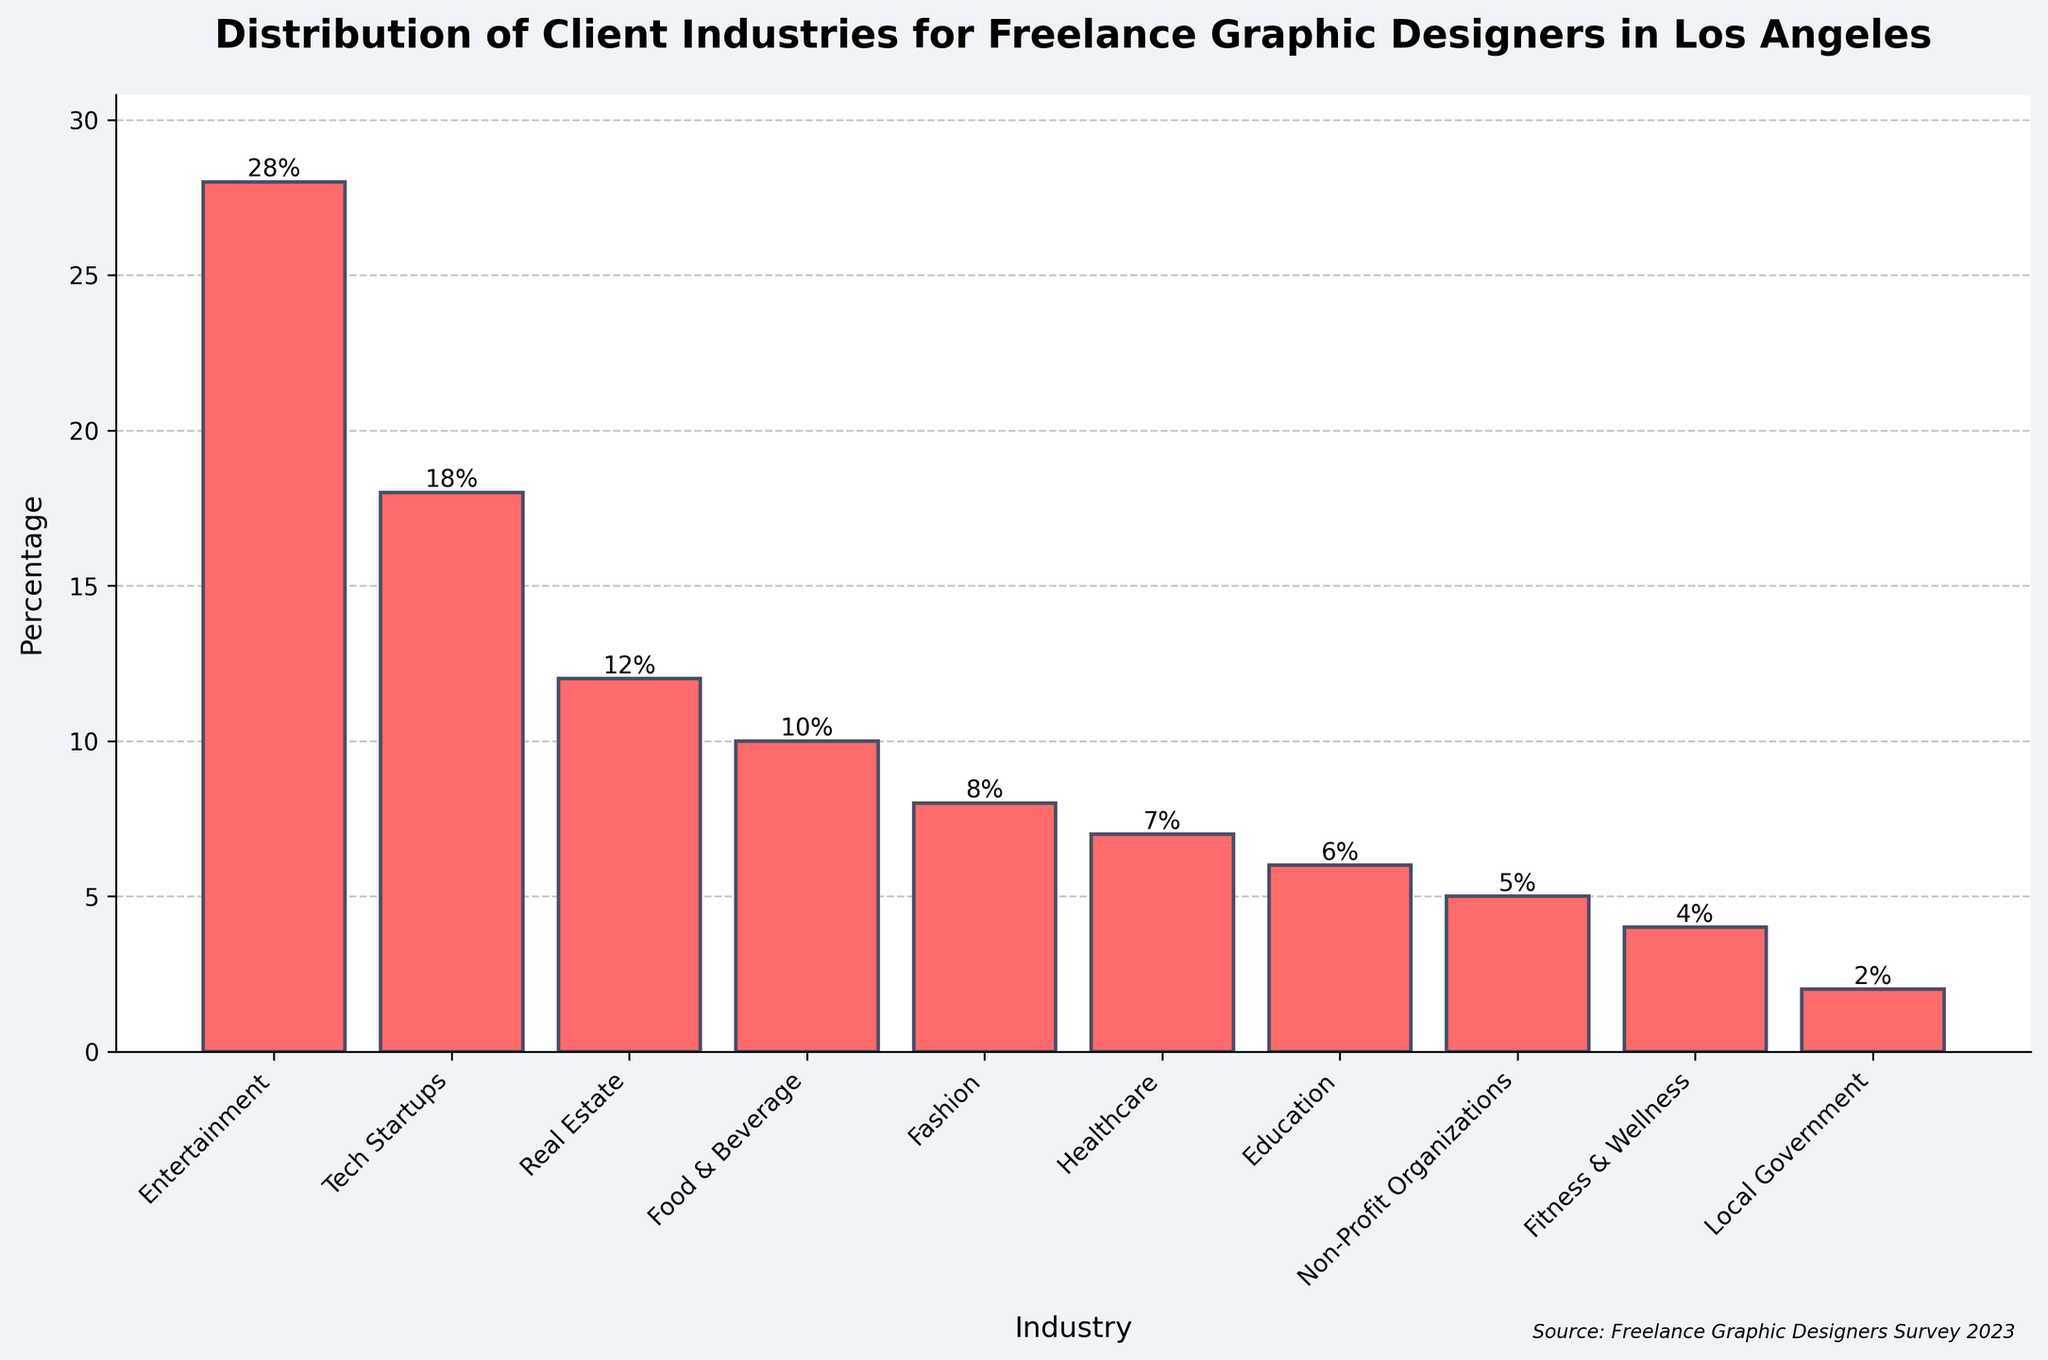Which industry has the highest percentage of clients for freelance graphic designers in Los Angeles? To find the industry with the highest percentage, look for the tallest bar in the chart. The "Entertainment" industry has the tallest bar with a percentage of 28%.
Answer: Entertainment What is the percentage difference between clients in the Tech Startups industry and the Real Estate industry? The Tech Startups industry has 18%, and the Real Estate industry has 12%. The difference is calculated by subtracting the smaller percentage from the larger one: 18% - 12% = 6%.
Answer: 6% Which two industries combined have a total percentage closest to 20%? To find the combined percentage close to 20%, look for two bars whose heights sum to around 20%. In this case, "Healthcare" (7%) and "Education" (6%) combined give 7% + 6% = 13%, "Non-Profit Organizations" (5%) and "Fitness & Wellness" (4%) give 5% + 4% = 9%, but the closest combination to 20% is "Fashion" (8%) and "Non-Profit Organizations" (5%) giving 8% + 5% = 13%. Thus, there is no exact match for 20% but 13% is the nearest.
Answer: Fashion and Non-Profit Organizations Are there any industries with equal percentages of clients? To determine if any industries have equal percentages, compare the heights of the bars. In the chart, no two bars have the same height, indicating that there are no industries with equal percentages.
Answer: No Which industry has the smallest percentage of clients for freelance graphic designers in Los Angeles? To identify the industry with the smallest percentage, look for the shortest bar in the chart. The "Local Government" industry has the shortest bar with a percentage of 2%.
Answer: Local Government What is the total percentage of clients from the top three industries? The top three industries are Entertainment (28%), Tech Startups (18%), and Real Estate (12%). Sum these percentages: 28% + 18% + 12% = 58%.
Answer: 58% How does the percentage of clients in the Healthcare industry compare to the percentage in the Food & Beverage industry? Compare the heights of the bars for the Healthcare industry (7%) and Food & Beverage industry (10%). The Food & Beverage industry has a higher percentage: 10% > 7%.
Answer: The Food & Beverage industry has a higher percentage What is the average percentage of clients across all represented industries? To find the average, sum all the percentages and divide by the number of industries. The sum is 28% + 18% + 12% + 10% + 8% + 7% + 6% + 5% + 4% + 2% = 100%. There are 10 industries, so the average is 100% / 10 = 10%.
Answer: 10% Which two industries combined make up 40% of the total clients? To find two industries that sum to 40%, look for bars whose heights add up to 40%. "Entertainment" (28%) and "Food & Beverage" (10%) combined give 28% + 10% = 38%, which is the closest we can find. Another combination is "Tech Startups" (18%) and "Real Estate" (12%), giving 18% + 12% = 30%, which is not sufficient. Thus, none make exactly 40%; the closest is 38%.
Answer: No exact match, closest is Entertainment and Food & Beverage at 38% 